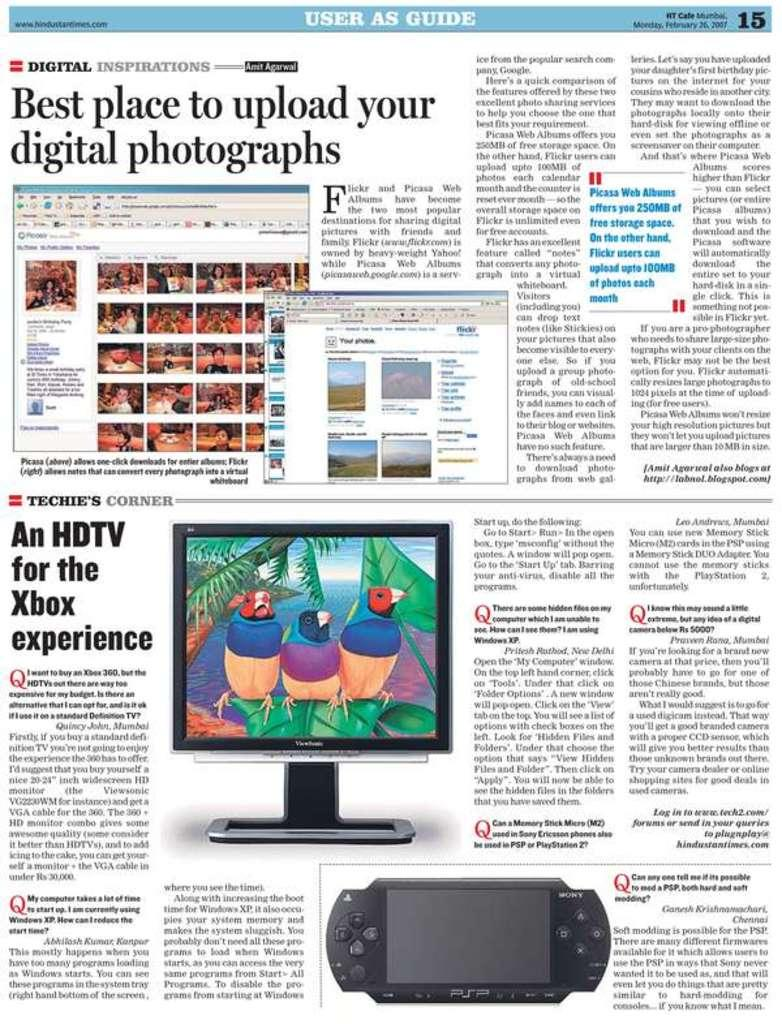<image>
Provide a brief description of the given image. an article that says best place to upload your digital photographs 